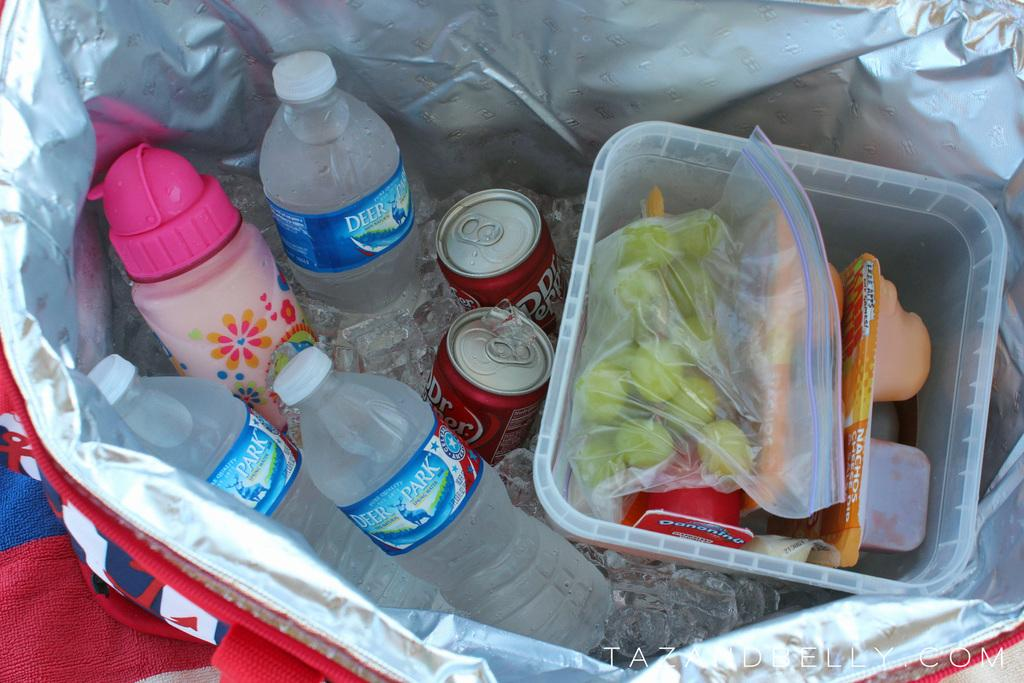What object is present in the image that can hold items? There is a basket in the image that can hold items. What types of items are in the basket? The basket contains bottles, tin cans, ice cubes, and fruits. Is there any other container with items in the image? Yes, there is a box with some food inside it in the image. What type of hydrant can be seen in the image? There is no hydrant present in the image. What point is being made by the arrangement of items in the basket? The arrangement of items in the basket does not convey a specific point; it is simply a collection of items. 